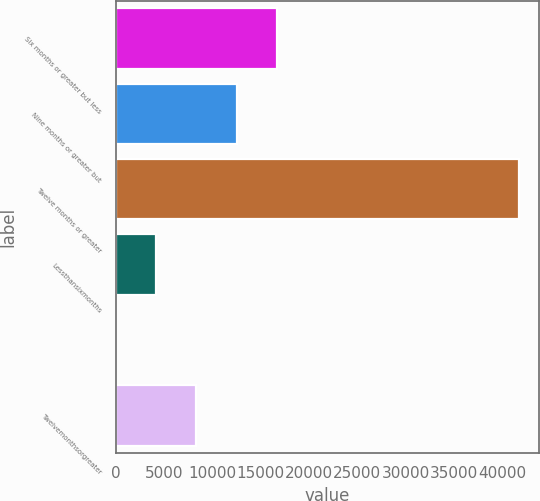Convert chart to OTSL. <chart><loc_0><loc_0><loc_500><loc_500><bar_chart><fcel>Six months or greater but less<fcel>Nine months or greater but<fcel>Twelve months or greater<fcel>Lessthansixmonths<fcel>Unnamed: 4<fcel>Twelvemonthsorgreater<nl><fcel>16692<fcel>12520.5<fcel>41721<fcel>4177.5<fcel>6<fcel>8349<nl></chart> 